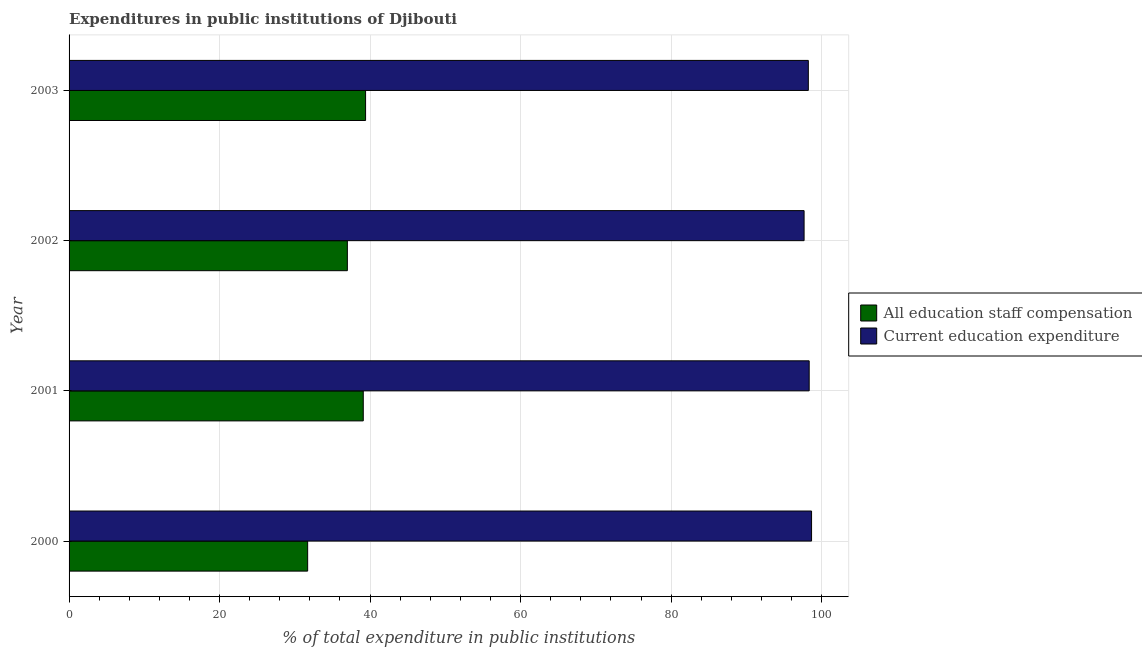How many groups of bars are there?
Give a very brief answer. 4. Are the number of bars on each tick of the Y-axis equal?
Offer a terse response. Yes. How many bars are there on the 1st tick from the top?
Make the answer very short. 2. How many bars are there on the 2nd tick from the bottom?
Give a very brief answer. 2. What is the label of the 2nd group of bars from the top?
Your answer should be compact. 2002. What is the expenditure in staff compensation in 2002?
Offer a very short reply. 36.98. Across all years, what is the maximum expenditure in education?
Give a very brief answer. 98.66. Across all years, what is the minimum expenditure in staff compensation?
Offer a terse response. 31.7. In which year was the expenditure in education minimum?
Make the answer very short. 2002. What is the total expenditure in education in the graph?
Provide a short and direct response. 392.91. What is the difference between the expenditure in education in 2001 and that in 2003?
Your response must be concise. 0.11. What is the difference between the expenditure in education in 2002 and the expenditure in staff compensation in 2003?
Make the answer very short. 58.27. What is the average expenditure in staff compensation per year?
Give a very brief answer. 36.79. In the year 2002, what is the difference between the expenditure in staff compensation and expenditure in education?
Your answer should be compact. -60.69. What is the ratio of the expenditure in education in 2000 to that in 2002?
Provide a short and direct response. 1.01. Is the expenditure in staff compensation in 2000 less than that in 2001?
Offer a very short reply. Yes. What is the difference between the highest and the second highest expenditure in education?
Provide a short and direct response. 0.32. What is the difference between the highest and the lowest expenditure in education?
Give a very brief answer. 0.99. In how many years, is the expenditure in staff compensation greater than the average expenditure in staff compensation taken over all years?
Ensure brevity in your answer.  3. What does the 2nd bar from the top in 2003 represents?
Provide a succinct answer. All education staff compensation. What does the 1st bar from the bottom in 2003 represents?
Offer a very short reply. All education staff compensation. How many bars are there?
Your answer should be compact. 8. What is the difference between two consecutive major ticks on the X-axis?
Your answer should be very brief. 20. Are the values on the major ticks of X-axis written in scientific E-notation?
Your answer should be compact. No. Does the graph contain any zero values?
Keep it short and to the point. No. Where does the legend appear in the graph?
Provide a succinct answer. Center right. How are the legend labels stacked?
Your answer should be compact. Vertical. What is the title of the graph?
Ensure brevity in your answer.  Expenditures in public institutions of Djibouti. Does "Researchers" appear as one of the legend labels in the graph?
Offer a very short reply. No. What is the label or title of the X-axis?
Your answer should be very brief. % of total expenditure in public institutions. What is the % of total expenditure in public institutions in All education staff compensation in 2000?
Your answer should be very brief. 31.7. What is the % of total expenditure in public institutions in Current education expenditure in 2000?
Give a very brief answer. 98.66. What is the % of total expenditure in public institutions of All education staff compensation in 2001?
Your response must be concise. 39.09. What is the % of total expenditure in public institutions in Current education expenditure in 2001?
Provide a succinct answer. 98.35. What is the % of total expenditure in public institutions in All education staff compensation in 2002?
Provide a succinct answer. 36.98. What is the % of total expenditure in public institutions in Current education expenditure in 2002?
Your response must be concise. 97.67. What is the % of total expenditure in public institutions of All education staff compensation in 2003?
Offer a terse response. 39.4. What is the % of total expenditure in public institutions of Current education expenditure in 2003?
Your answer should be compact. 98.23. Across all years, what is the maximum % of total expenditure in public institutions of All education staff compensation?
Your response must be concise. 39.4. Across all years, what is the maximum % of total expenditure in public institutions in Current education expenditure?
Offer a terse response. 98.66. Across all years, what is the minimum % of total expenditure in public institutions in All education staff compensation?
Give a very brief answer. 31.7. Across all years, what is the minimum % of total expenditure in public institutions in Current education expenditure?
Your answer should be very brief. 97.67. What is the total % of total expenditure in public institutions of All education staff compensation in the graph?
Keep it short and to the point. 147.18. What is the total % of total expenditure in public institutions of Current education expenditure in the graph?
Give a very brief answer. 392.91. What is the difference between the % of total expenditure in public institutions of All education staff compensation in 2000 and that in 2001?
Provide a short and direct response. -7.39. What is the difference between the % of total expenditure in public institutions in Current education expenditure in 2000 and that in 2001?
Make the answer very short. 0.32. What is the difference between the % of total expenditure in public institutions in All education staff compensation in 2000 and that in 2002?
Keep it short and to the point. -5.28. What is the difference between the % of total expenditure in public institutions in Current education expenditure in 2000 and that in 2002?
Provide a short and direct response. 0.99. What is the difference between the % of total expenditure in public institutions in All education staff compensation in 2000 and that in 2003?
Your response must be concise. -7.7. What is the difference between the % of total expenditure in public institutions of Current education expenditure in 2000 and that in 2003?
Give a very brief answer. 0.43. What is the difference between the % of total expenditure in public institutions of All education staff compensation in 2001 and that in 2002?
Your answer should be very brief. 2.11. What is the difference between the % of total expenditure in public institutions of Current education expenditure in 2001 and that in 2002?
Your answer should be very brief. 0.68. What is the difference between the % of total expenditure in public institutions of All education staff compensation in 2001 and that in 2003?
Your answer should be compact. -0.31. What is the difference between the % of total expenditure in public institutions in Current education expenditure in 2001 and that in 2003?
Provide a short and direct response. 0.11. What is the difference between the % of total expenditure in public institutions of All education staff compensation in 2002 and that in 2003?
Your response must be concise. -2.42. What is the difference between the % of total expenditure in public institutions in Current education expenditure in 2002 and that in 2003?
Offer a terse response. -0.56. What is the difference between the % of total expenditure in public institutions of All education staff compensation in 2000 and the % of total expenditure in public institutions of Current education expenditure in 2001?
Ensure brevity in your answer.  -66.64. What is the difference between the % of total expenditure in public institutions in All education staff compensation in 2000 and the % of total expenditure in public institutions in Current education expenditure in 2002?
Provide a succinct answer. -65.97. What is the difference between the % of total expenditure in public institutions in All education staff compensation in 2000 and the % of total expenditure in public institutions in Current education expenditure in 2003?
Provide a short and direct response. -66.53. What is the difference between the % of total expenditure in public institutions of All education staff compensation in 2001 and the % of total expenditure in public institutions of Current education expenditure in 2002?
Make the answer very short. -58.58. What is the difference between the % of total expenditure in public institutions in All education staff compensation in 2001 and the % of total expenditure in public institutions in Current education expenditure in 2003?
Give a very brief answer. -59.14. What is the difference between the % of total expenditure in public institutions of All education staff compensation in 2002 and the % of total expenditure in public institutions of Current education expenditure in 2003?
Ensure brevity in your answer.  -61.25. What is the average % of total expenditure in public institutions in All education staff compensation per year?
Offer a terse response. 36.79. What is the average % of total expenditure in public institutions in Current education expenditure per year?
Your answer should be very brief. 98.23. In the year 2000, what is the difference between the % of total expenditure in public institutions of All education staff compensation and % of total expenditure in public institutions of Current education expenditure?
Provide a short and direct response. -66.96. In the year 2001, what is the difference between the % of total expenditure in public institutions in All education staff compensation and % of total expenditure in public institutions in Current education expenditure?
Your answer should be very brief. -59.25. In the year 2002, what is the difference between the % of total expenditure in public institutions of All education staff compensation and % of total expenditure in public institutions of Current education expenditure?
Provide a short and direct response. -60.69. In the year 2003, what is the difference between the % of total expenditure in public institutions in All education staff compensation and % of total expenditure in public institutions in Current education expenditure?
Your answer should be compact. -58.83. What is the ratio of the % of total expenditure in public institutions of All education staff compensation in 2000 to that in 2001?
Your answer should be compact. 0.81. What is the ratio of the % of total expenditure in public institutions of All education staff compensation in 2000 to that in 2002?
Make the answer very short. 0.86. What is the ratio of the % of total expenditure in public institutions in Current education expenditure in 2000 to that in 2002?
Provide a short and direct response. 1.01. What is the ratio of the % of total expenditure in public institutions in All education staff compensation in 2000 to that in 2003?
Offer a very short reply. 0.8. What is the ratio of the % of total expenditure in public institutions in Current education expenditure in 2000 to that in 2003?
Offer a very short reply. 1. What is the ratio of the % of total expenditure in public institutions in All education staff compensation in 2001 to that in 2002?
Provide a short and direct response. 1.06. What is the ratio of the % of total expenditure in public institutions in All education staff compensation in 2001 to that in 2003?
Provide a succinct answer. 0.99. What is the ratio of the % of total expenditure in public institutions of Current education expenditure in 2001 to that in 2003?
Give a very brief answer. 1. What is the ratio of the % of total expenditure in public institutions of All education staff compensation in 2002 to that in 2003?
Provide a succinct answer. 0.94. What is the ratio of the % of total expenditure in public institutions of Current education expenditure in 2002 to that in 2003?
Provide a succinct answer. 0.99. What is the difference between the highest and the second highest % of total expenditure in public institutions of All education staff compensation?
Your answer should be compact. 0.31. What is the difference between the highest and the second highest % of total expenditure in public institutions in Current education expenditure?
Your response must be concise. 0.32. What is the difference between the highest and the lowest % of total expenditure in public institutions in All education staff compensation?
Offer a very short reply. 7.7. What is the difference between the highest and the lowest % of total expenditure in public institutions in Current education expenditure?
Offer a very short reply. 0.99. 